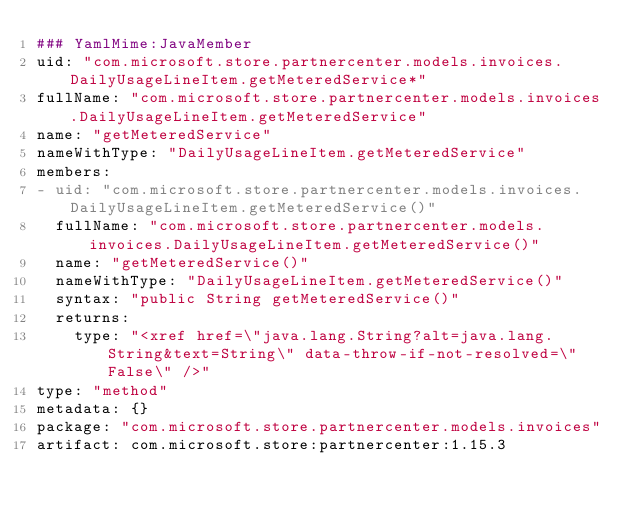Convert code to text. <code><loc_0><loc_0><loc_500><loc_500><_YAML_>### YamlMime:JavaMember
uid: "com.microsoft.store.partnercenter.models.invoices.DailyUsageLineItem.getMeteredService*"
fullName: "com.microsoft.store.partnercenter.models.invoices.DailyUsageLineItem.getMeteredService"
name: "getMeteredService"
nameWithType: "DailyUsageLineItem.getMeteredService"
members:
- uid: "com.microsoft.store.partnercenter.models.invoices.DailyUsageLineItem.getMeteredService()"
  fullName: "com.microsoft.store.partnercenter.models.invoices.DailyUsageLineItem.getMeteredService()"
  name: "getMeteredService()"
  nameWithType: "DailyUsageLineItem.getMeteredService()"
  syntax: "public String getMeteredService()"
  returns:
    type: "<xref href=\"java.lang.String?alt=java.lang.String&text=String\" data-throw-if-not-resolved=\"False\" />"
type: "method"
metadata: {}
package: "com.microsoft.store.partnercenter.models.invoices"
artifact: com.microsoft.store:partnercenter:1.15.3
</code> 